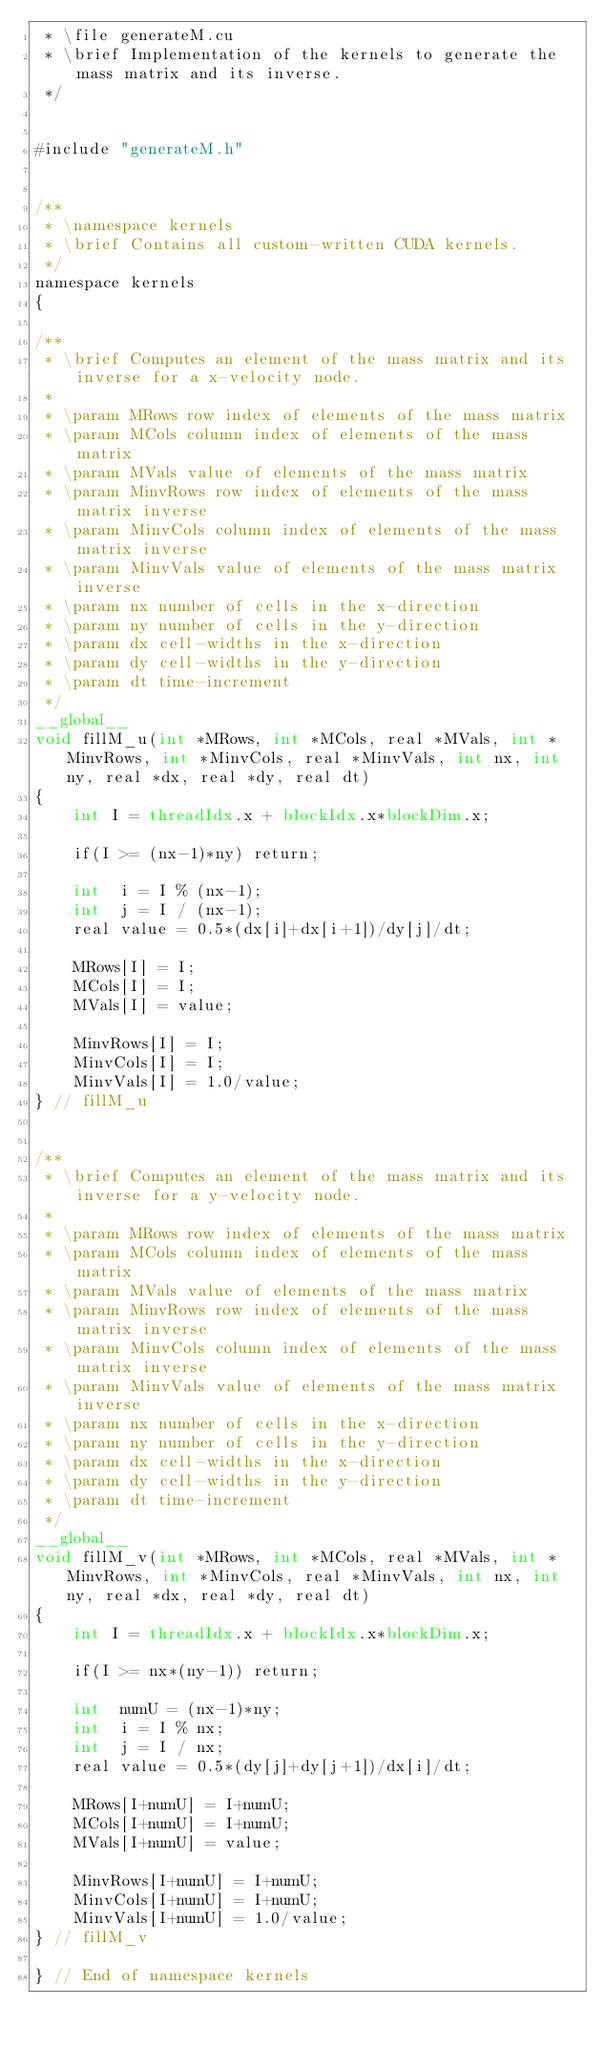<code> <loc_0><loc_0><loc_500><loc_500><_Cuda_> * \file generateM.cu
 * \brief Implementation of the kernels to generate the mass matrix and its inverse.
 */


#include "generateM.h"


/**
 * \namespace kernels
 * \brief Contains all custom-written CUDA kernels.
 */
namespace kernels
{

/**
 * \brief Computes an element of the mass matrix and its inverse for a x-velocity node.
 *
 * \param MRows row index of elements of the mass matrix
 * \param MCols column index of elements of the mass matrix
 * \param MVals value of elements of the mass matrix
 * \param MinvRows row index of elements of the mass matrix inverse
 * \param MinvCols column index of elements of the mass matrix inverse
 * \param MinvVals value of elements of the mass matrix inverse
 * \param nx number of cells in the x-direction
 * \param ny number of cells in the y-direction
 * \param dx cell-widths in the x-direction
 * \param dy cell-widths in the y-direction
 * \param dt time-increment
 */
__global__
void fillM_u(int *MRows, int *MCols, real *MVals, int *MinvRows, int *MinvCols, real *MinvVals, int nx, int ny, real *dx, real *dy, real dt)
{
	int I = threadIdx.x + blockIdx.x*blockDim.x;
	
	if(I >= (nx-1)*ny) return;
	
	int  i = I % (nx-1);
	int  j = I / (nx-1);
	real value = 0.5*(dx[i]+dx[i+1])/dy[j]/dt;
	
	MRows[I] = I;
	MCols[I] = I;
	MVals[I] = value;
	
	MinvRows[I] = I;
	MinvCols[I] = I;
	MinvVals[I] = 1.0/value;
} // fillM_u


/**
 * \brief Computes an element of the mass matrix and its inverse for a y-velocity node.
 *
 * \param MRows row index of elements of the mass matrix
 * \param MCols column index of elements of the mass matrix
 * \param MVals value of elements of the mass matrix
 * \param MinvRows row index of elements of the mass matrix inverse
 * \param MinvCols column index of elements of the mass matrix inverse
 * \param MinvVals value of elements of the mass matrix inverse
 * \param nx number of cells in the x-direction
 * \param ny number of cells in the y-direction
 * \param dx cell-widths in the x-direction
 * \param dy cell-widths in the y-direction
 * \param dt time-increment
 */
__global__
void fillM_v(int *MRows, int *MCols, real *MVals, int *MinvRows, int *MinvCols, real *MinvVals, int nx, int ny, real *dx, real *dy, real dt)
{
	int I = threadIdx.x + blockIdx.x*blockDim.x;
	
	if(I >= nx*(ny-1)) return;
	
	int  numU = (nx-1)*ny;
	int  i = I % nx;
	int  j = I / nx;
	real value = 0.5*(dy[j]+dy[j+1])/dx[i]/dt;
	
	MRows[I+numU] = I+numU;
	MCols[I+numU] = I+numU;
	MVals[I+numU] = value;
	
	MinvRows[I+numU] = I+numU;
	MinvCols[I+numU] = I+numU;
	MinvVals[I+numU] = 1.0/value;
} // fillM_v

} // End of namespace kernels
</code> 